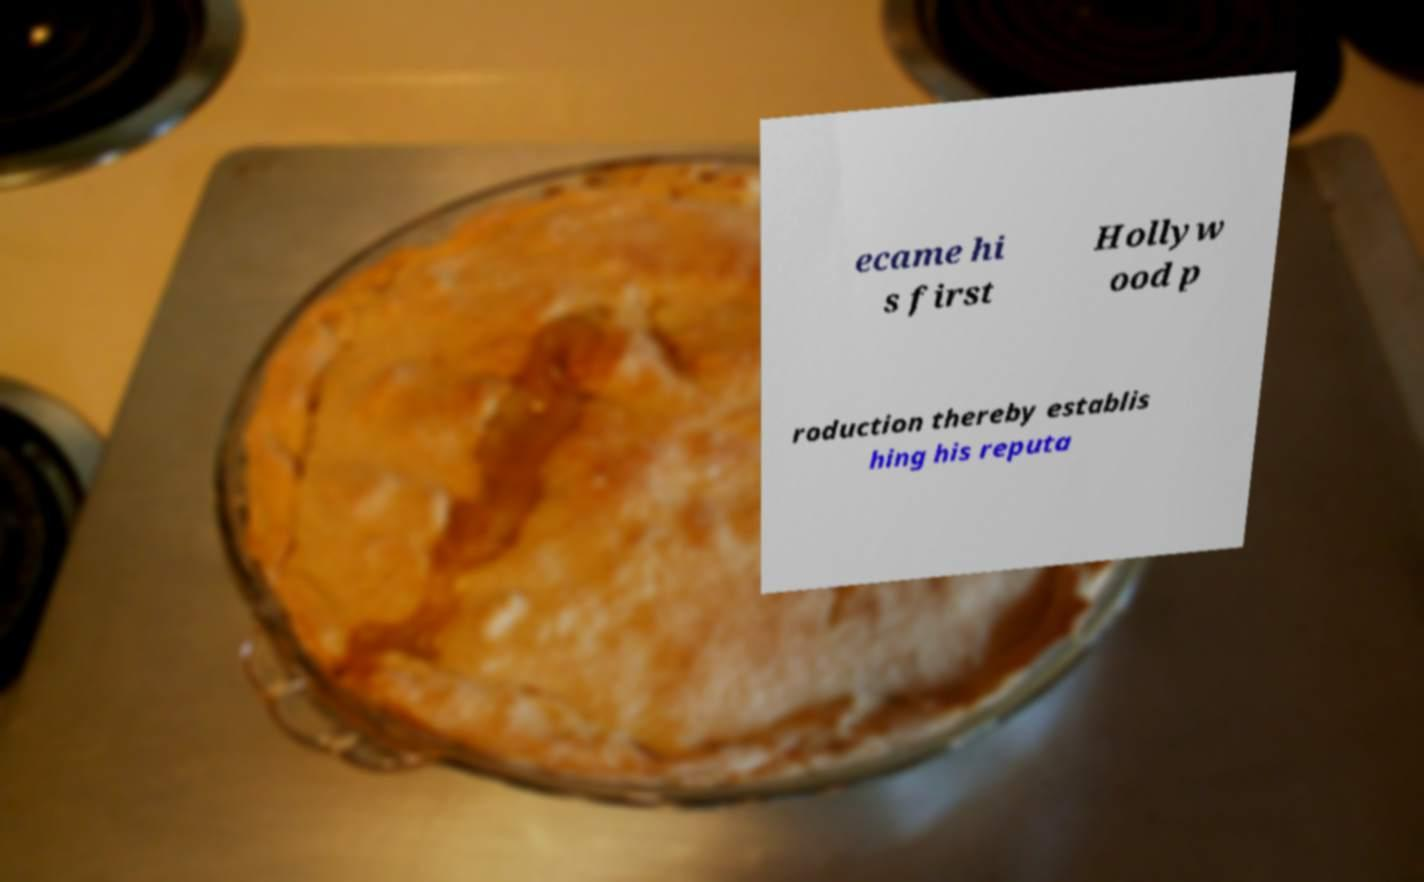Could you assist in decoding the text presented in this image and type it out clearly? ecame hi s first Hollyw ood p roduction thereby establis hing his reputa 